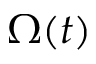Convert formula to latex. <formula><loc_0><loc_0><loc_500><loc_500>\Omega ( t )</formula> 